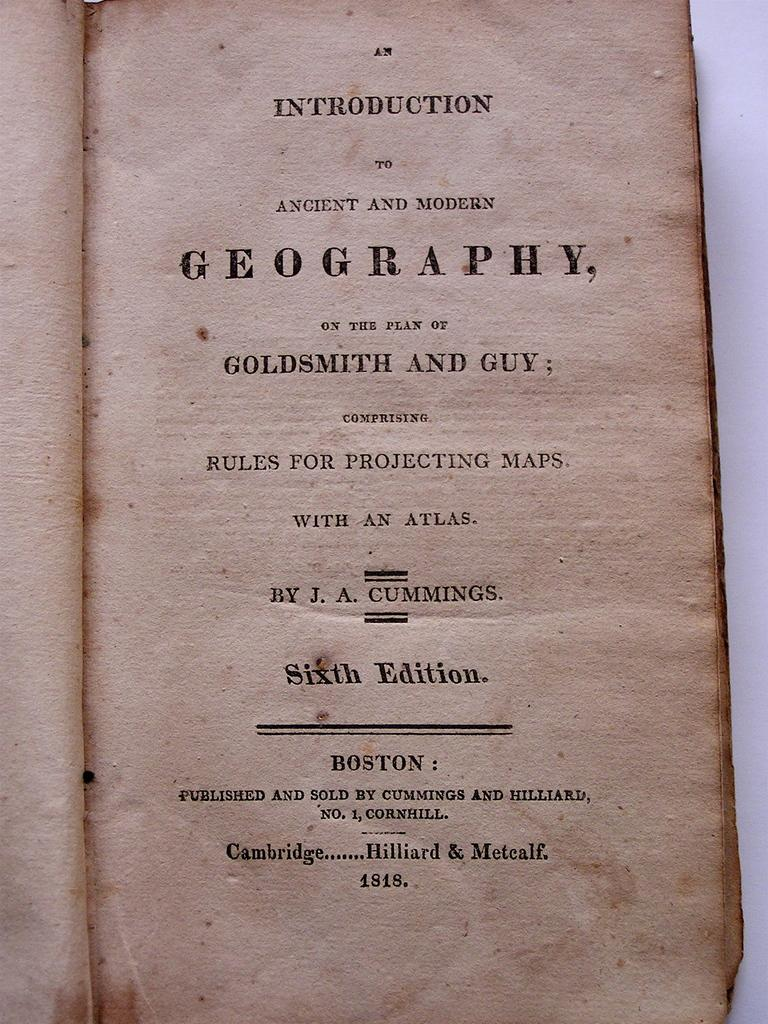<image>
Write a terse but informative summary of the picture. a book about Geography open to the Introduction page 